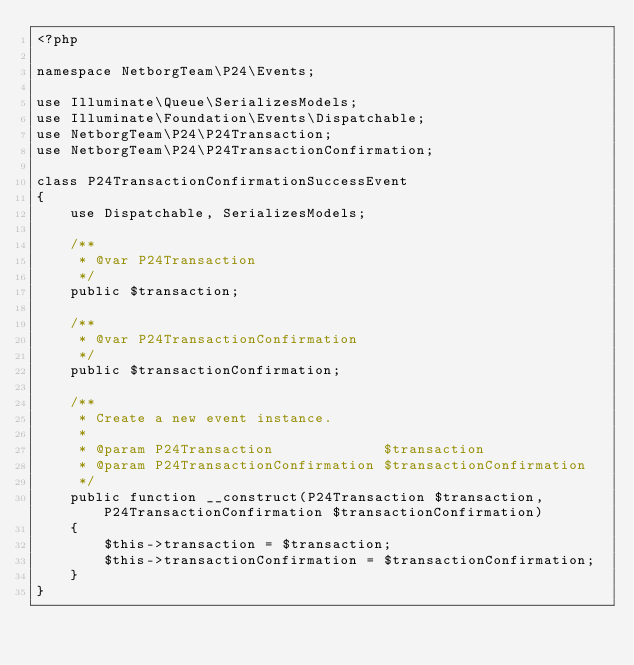Convert code to text. <code><loc_0><loc_0><loc_500><loc_500><_PHP_><?php

namespace NetborgTeam\P24\Events;

use Illuminate\Queue\SerializesModels;
use Illuminate\Foundation\Events\Dispatchable;
use NetborgTeam\P24\P24Transaction;
use NetborgTeam\P24\P24TransactionConfirmation;

class P24TransactionConfirmationSuccessEvent
{
    use Dispatchable, SerializesModels;

    /**
     * @var P24Transaction
     */
    public $transaction;

    /**
     * @var P24TransactionConfirmation
     */
    public $transactionConfirmation;

    /**
     * Create a new event instance.
     *
     * @param P24Transaction             $transaction
     * @param P24TransactionConfirmation $transactionConfirmation
     */
    public function __construct(P24Transaction $transaction, P24TransactionConfirmation $transactionConfirmation)
    {
        $this->transaction = $transaction;
        $this->transactionConfirmation = $transactionConfirmation;
    }
}
</code> 